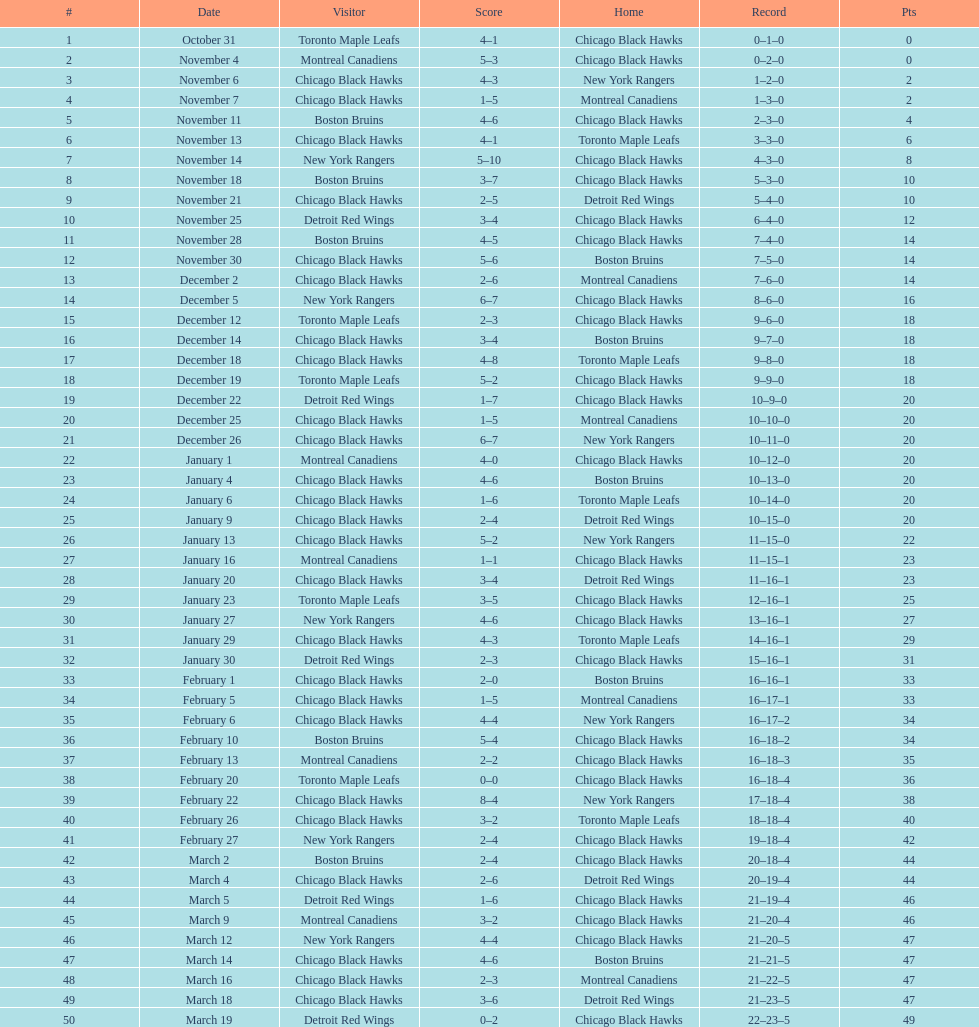How many games total were played? 50. 